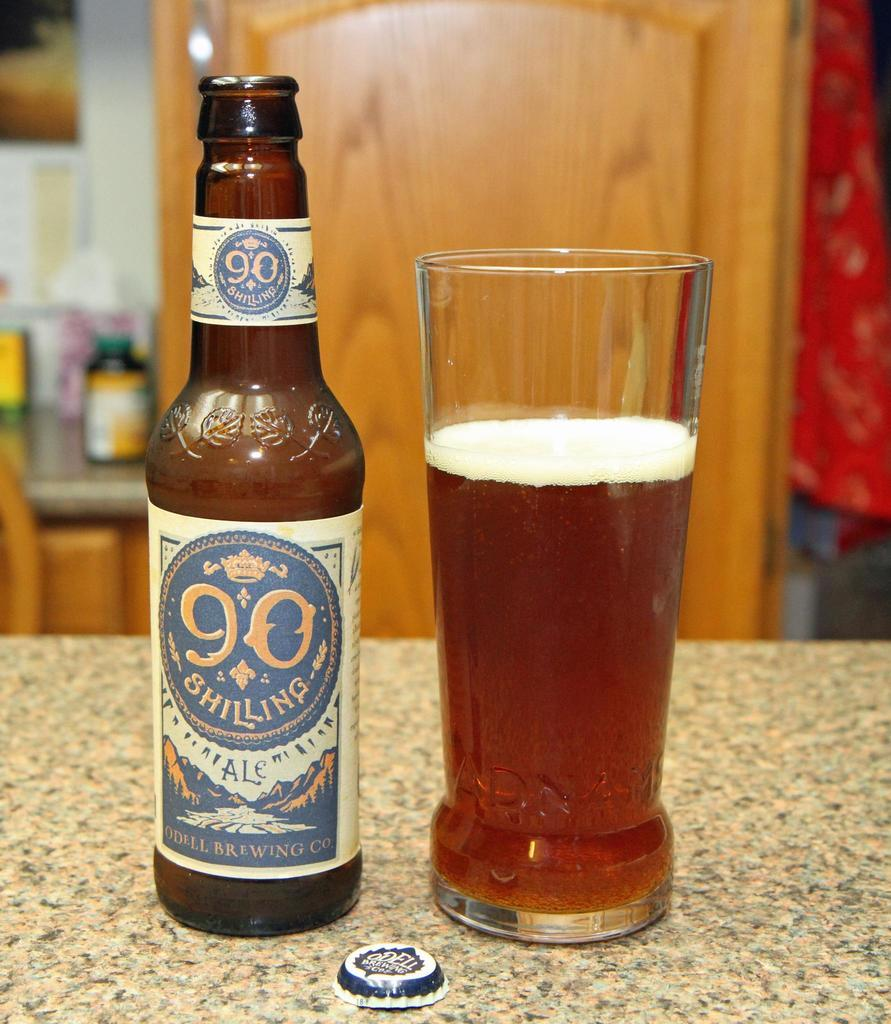Provide a one-sentence caption for the provided image. A glass of 90 Shilling beer is great to drink on a warm day. 